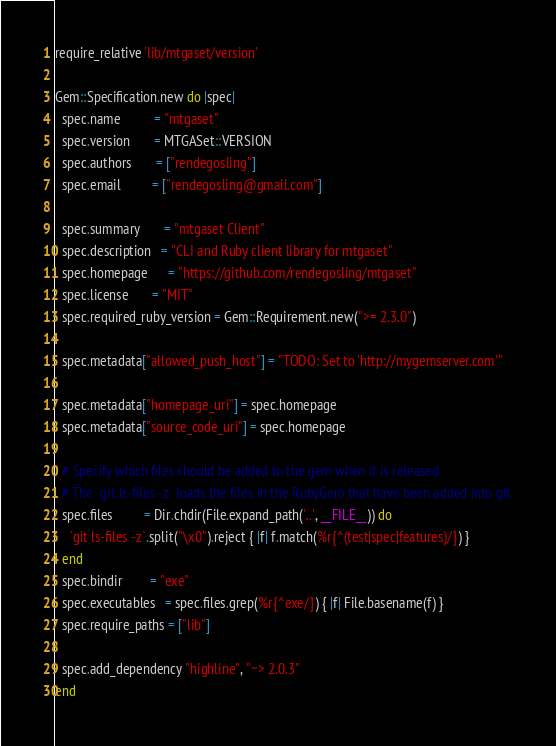Convert code to text. <code><loc_0><loc_0><loc_500><loc_500><_Ruby_>require_relative 'lib/mtgaset/version'

Gem::Specification.new do |spec|
  spec.name          = "mtgaset"
  spec.version       = MTGASet::VERSION
  spec.authors       = ["rendegosling"]
  spec.email         = ["rendegosling@gmail.com"]

  spec.summary       = "mtgaset Client"
  spec.description   = "CLI and Ruby client library for mtgaset"
  spec.homepage      = "https://github.com/rendegosling/mtgaset"
  spec.license       = "MIT"
  spec.required_ruby_version = Gem::Requirement.new(">= 2.3.0")

  spec.metadata["allowed_push_host"] = "TODO: Set to 'http://mygemserver.com'"

  spec.metadata["homepage_uri"] = spec.homepage
  spec.metadata["source_code_uri"] = spec.homepage

  # Specify which files should be added to the gem when it is released.
  # The `git ls-files -z` loads the files in the RubyGem that have been added into git.
  spec.files         = Dir.chdir(File.expand_path('..', __FILE__)) do
    `git ls-files -z`.split("\x0").reject { |f| f.match(%r{^(test|spec|features)/}) }
  end
  spec.bindir        = "exe"
  spec.executables   = spec.files.grep(%r{^exe/}) { |f| File.basename(f) }
  spec.require_paths = ["lib"]

  spec.add_dependency "highline", "~> 2.0.3"
end
</code> 